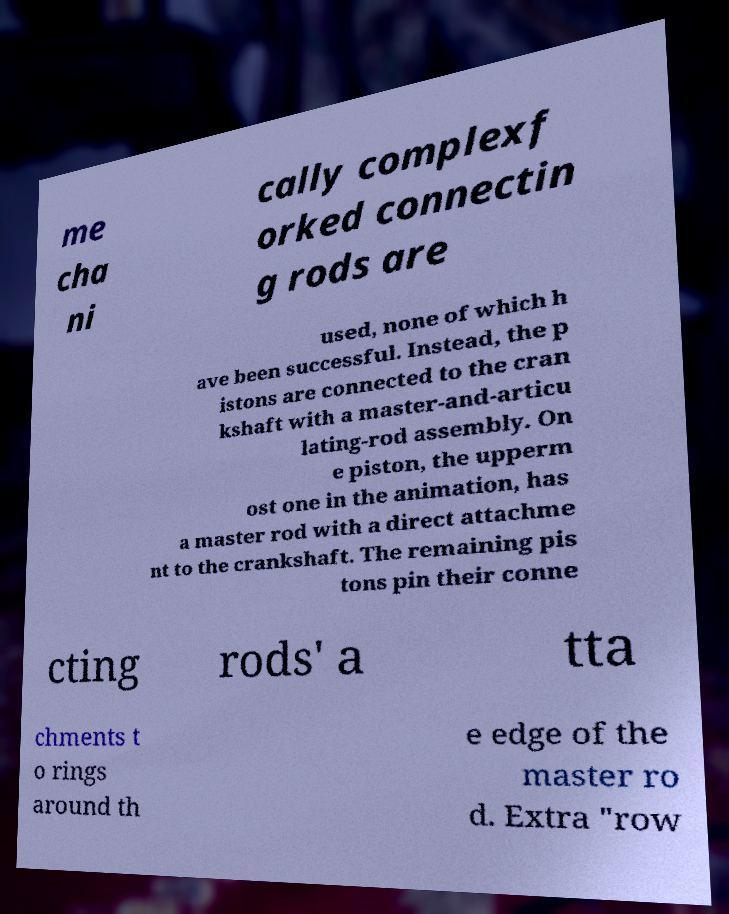Please read and relay the text visible in this image. What does it say? me cha ni cally complexf orked connectin g rods are used, none of which h ave been successful. Instead, the p istons are connected to the cran kshaft with a master-and-articu lating-rod assembly. On e piston, the upperm ost one in the animation, has a master rod with a direct attachme nt to the crankshaft. The remaining pis tons pin their conne cting rods' a tta chments t o rings around th e edge of the master ro d. Extra "row 